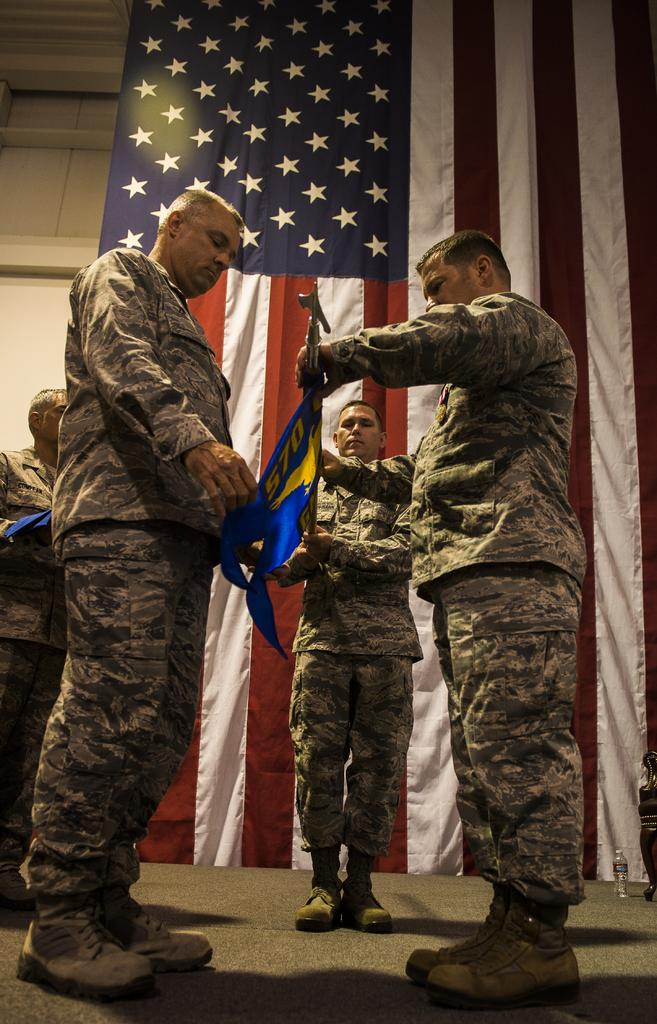How many people are standing on the path in the image? There are four people standing on the path in the image. What are two of the people doing? Two of the people are holding an item. What can be seen in the background of the image? There is a United States flag and a wall in the background. What type of silver item is being used by the people in the image? There is no silver item present in the image. How does the box help the people in the image? There is no box present in the image, so it cannot help the people. 